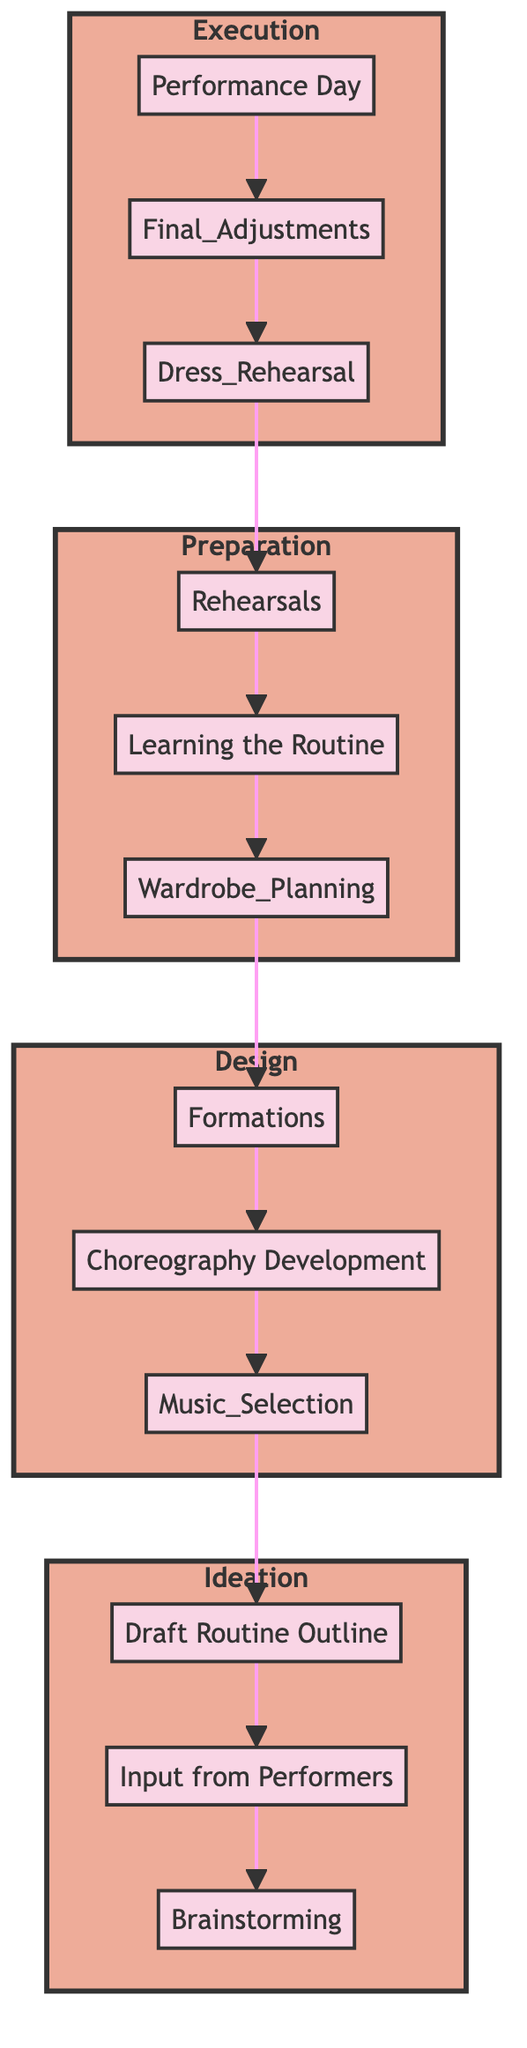What is the first step in creating a cheer routine? The first step indicated in the diagram is "Brainstorming," where the team gathers to discuss the theme, music, and major elements of the routine.
Answer: Brainstorming How many phases are represented in the diagram? The diagram includes four phases: Ideation, Design, Preparation, and Execution.
Answer: 4 What is the last step before "Performance Day"? According to the flow, the last step before "Performance Day" is "Final Adjustments," which involves tweaking elements based on dress rehearsal feedback.
Answer: Final Adjustments Which phase involves learning choreography? The phase that involves learning choreography is "Preparation," specifically marked by the step "Learning the Routine."
Answer: Preparation What key activity occurs during the Design phase related to music? During the Design phase, the key activity related to music is "Music Selection," where tracks that match the theme and desired energy are chosen.
Answer: Music Selection What step follows "Choreography Development"? The step that follows "Choreography Development" is "Formations," where the planning of positions and movements during the routine takes place.
Answer: Formations In which phase is the "Dress Rehearsal" found? The "Dress Rehearsal" is found in the Execution phase, which indicates a full run-through with outfits, music, and formations.
Answer: Execution What is required after "Learning the Routine"? After "Learning the Routine," the next step is "Rehearsals," where the team practices the routines to achieve perfection and note any improvements.
Answer: Rehearsals How does "Input from Performers" contribute to the process? "Input from Performers" contributes to the creation of the routine by allowing cheerleaders to contribute ideas based on their strengths and preferences, which informs the "Draft Routine Outline."
Answer: It helps create the Draft Routine Outline 